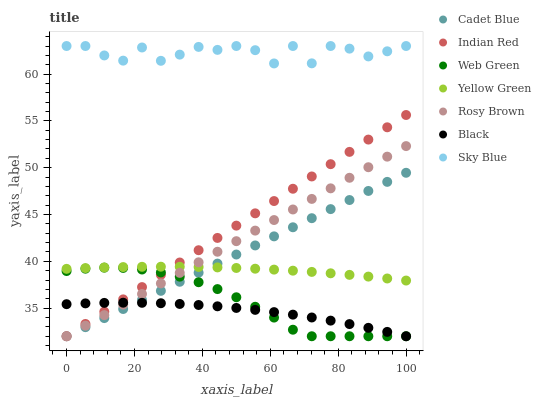Does Black have the minimum area under the curve?
Answer yes or no. Yes. Does Sky Blue have the maximum area under the curve?
Answer yes or no. Yes. Does Yellow Green have the minimum area under the curve?
Answer yes or no. No. Does Yellow Green have the maximum area under the curve?
Answer yes or no. No. Is Rosy Brown the smoothest?
Answer yes or no. Yes. Is Sky Blue the roughest?
Answer yes or no. Yes. Is Yellow Green the smoothest?
Answer yes or no. No. Is Yellow Green the roughest?
Answer yes or no. No. Does Cadet Blue have the lowest value?
Answer yes or no. Yes. Does Yellow Green have the lowest value?
Answer yes or no. No. Does Sky Blue have the highest value?
Answer yes or no. Yes. Does Yellow Green have the highest value?
Answer yes or no. No. Is Web Green less than Yellow Green?
Answer yes or no. Yes. Is Sky Blue greater than Yellow Green?
Answer yes or no. Yes. Does Indian Red intersect Cadet Blue?
Answer yes or no. Yes. Is Indian Red less than Cadet Blue?
Answer yes or no. No. Is Indian Red greater than Cadet Blue?
Answer yes or no. No. Does Web Green intersect Yellow Green?
Answer yes or no. No. 